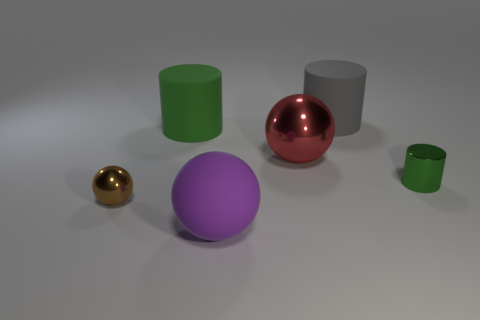Add 2 large red objects. How many objects exist? 8 Subtract all tiny green metal objects. Subtract all large red matte cylinders. How many objects are left? 5 Add 2 tiny brown metallic balls. How many tiny brown metallic balls are left? 3 Add 1 tiny things. How many tiny things exist? 3 Subtract 2 green cylinders. How many objects are left? 4 